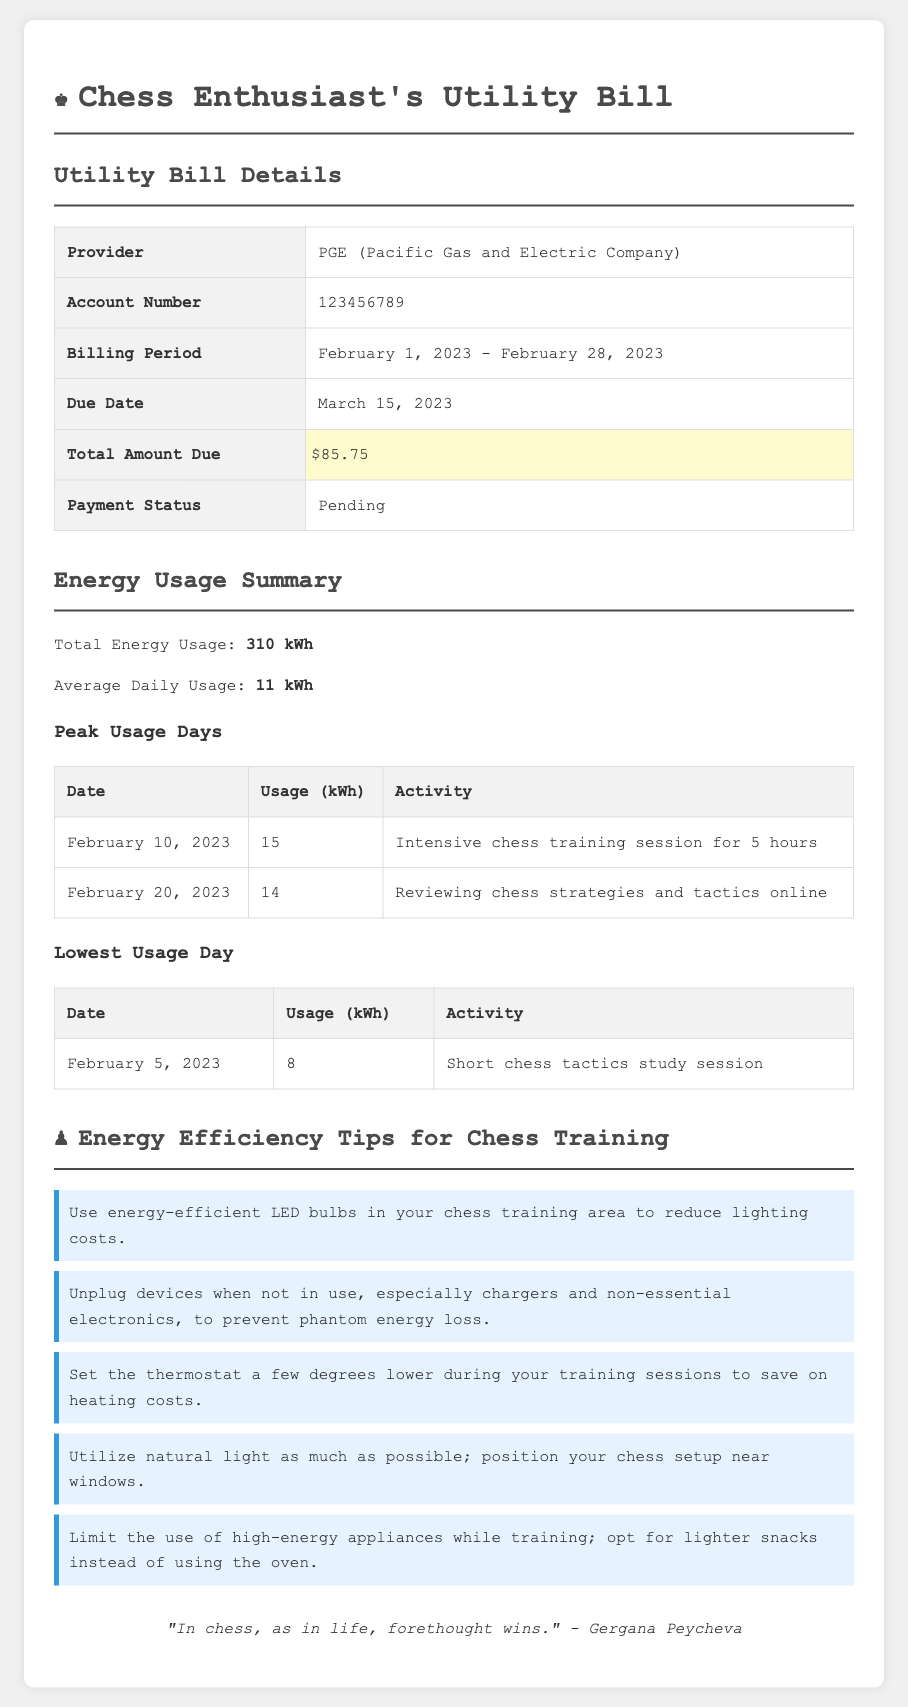what is the total amount due? The total amount due is stated in the document and is $85.75.
Answer: $85.75 what is the billing period? The billing period specifies the dates for which the bill is applicable, which is February 1, 2023 - February 28, 2023.
Answer: February 1, 2023 - February 28, 2023 which company is the utility provider? The utility provider is mentioned in the document, which is PGE (Pacific Gas and Electric Company).
Answer: PGE (Pacific Gas and Electric Company) what was the average daily usage? The document provides the average daily usage as 11 kWh.
Answer: 11 kWh how many kWh was used during the intensive chess training session? The intensive chess training session's usage is noted as 15 kWh on February 10, 2023.
Answer: 15 kWh which day had the lowest energy usage? The day with the lowest energy usage is highlighted in the document as February 5, 2023.
Answer: February 5, 2023 how many tips for energy efficiency are provided? The number of tips for energy efficiency listed is mentioned as five.
Answer: five what type of bulbs should be used to reduce lighting costs? The document recommends using energy-efficient LED bulbs for lighting.
Answer: energy-efficient LED bulbs which activity consumed 14 kWh? The activity that consumed 14 kWh is reviewing chess strategies and tactics online on February 20, 2023.
Answer: reviewing chess strategies and tactics online 